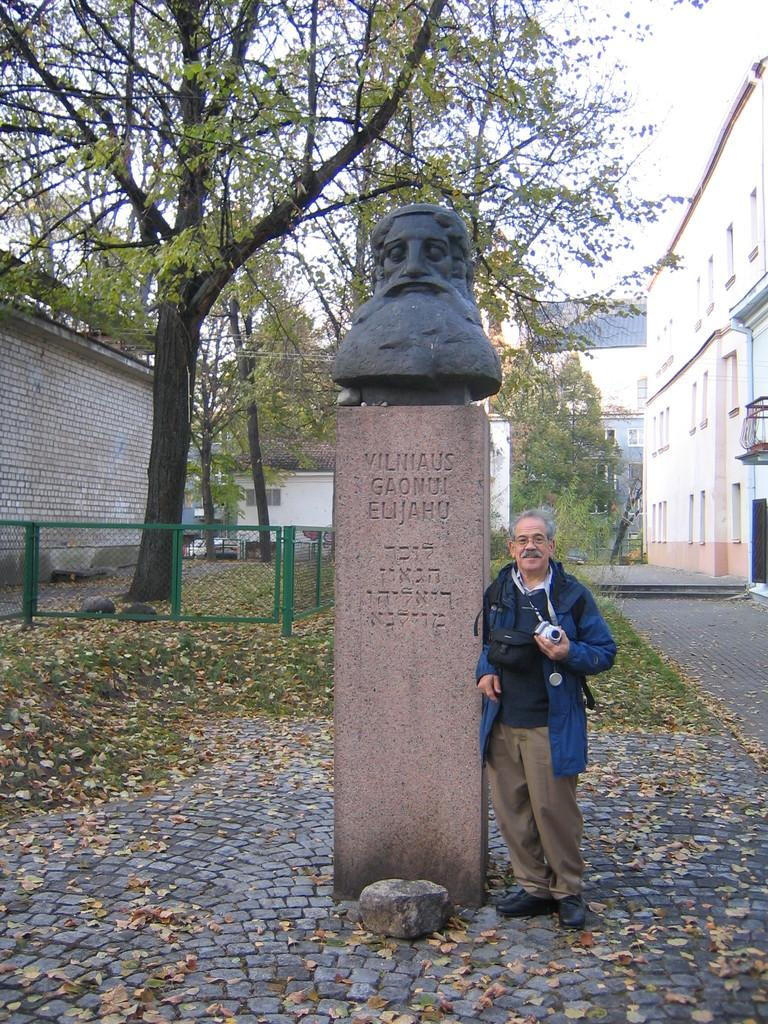What is the main subject in the image? There is a statue in the image. Who or what is beside the statue? A person is standing beside the statue. What is the person holding? The person is holding a camera. What is behind the person? There is a fencing behind the person. What can be seen in the background of the image? Trees and buildings are visible in the background. What type of vegetation is present in the image? Leaves and grass are visible in the image. What is the title of the grandmother's book in the image? There is no grandmother or book present in the image. 